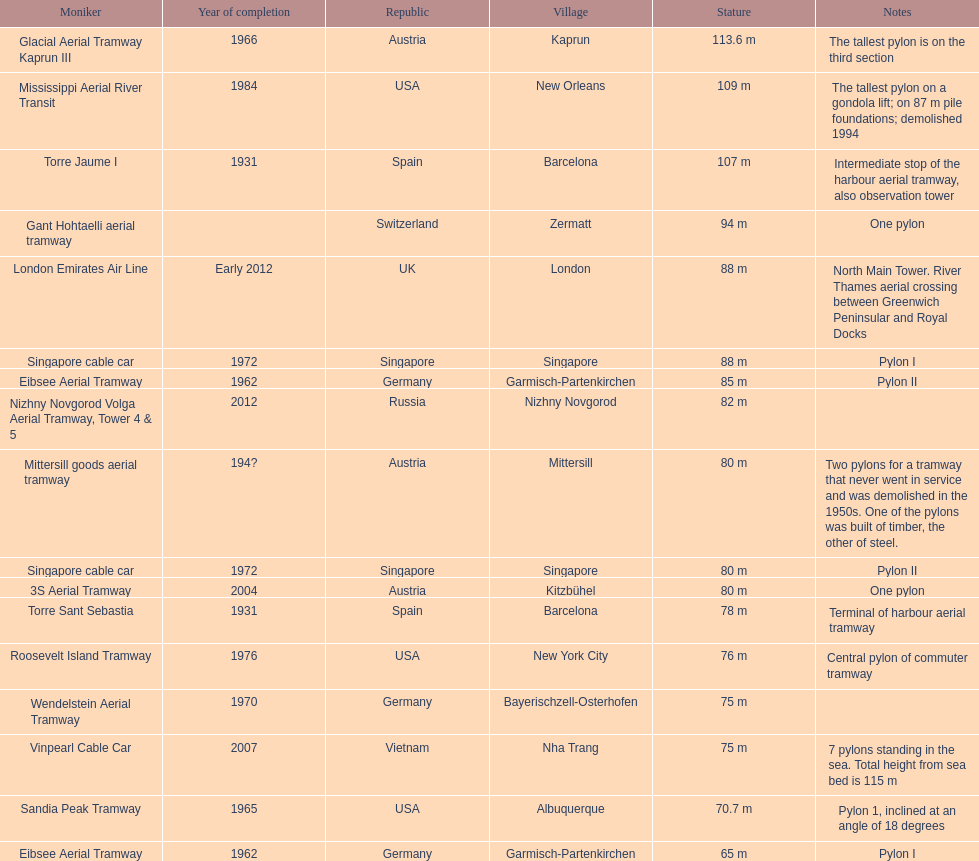How many metres is the mississippi aerial river transit from bottom to top? 109 m. 